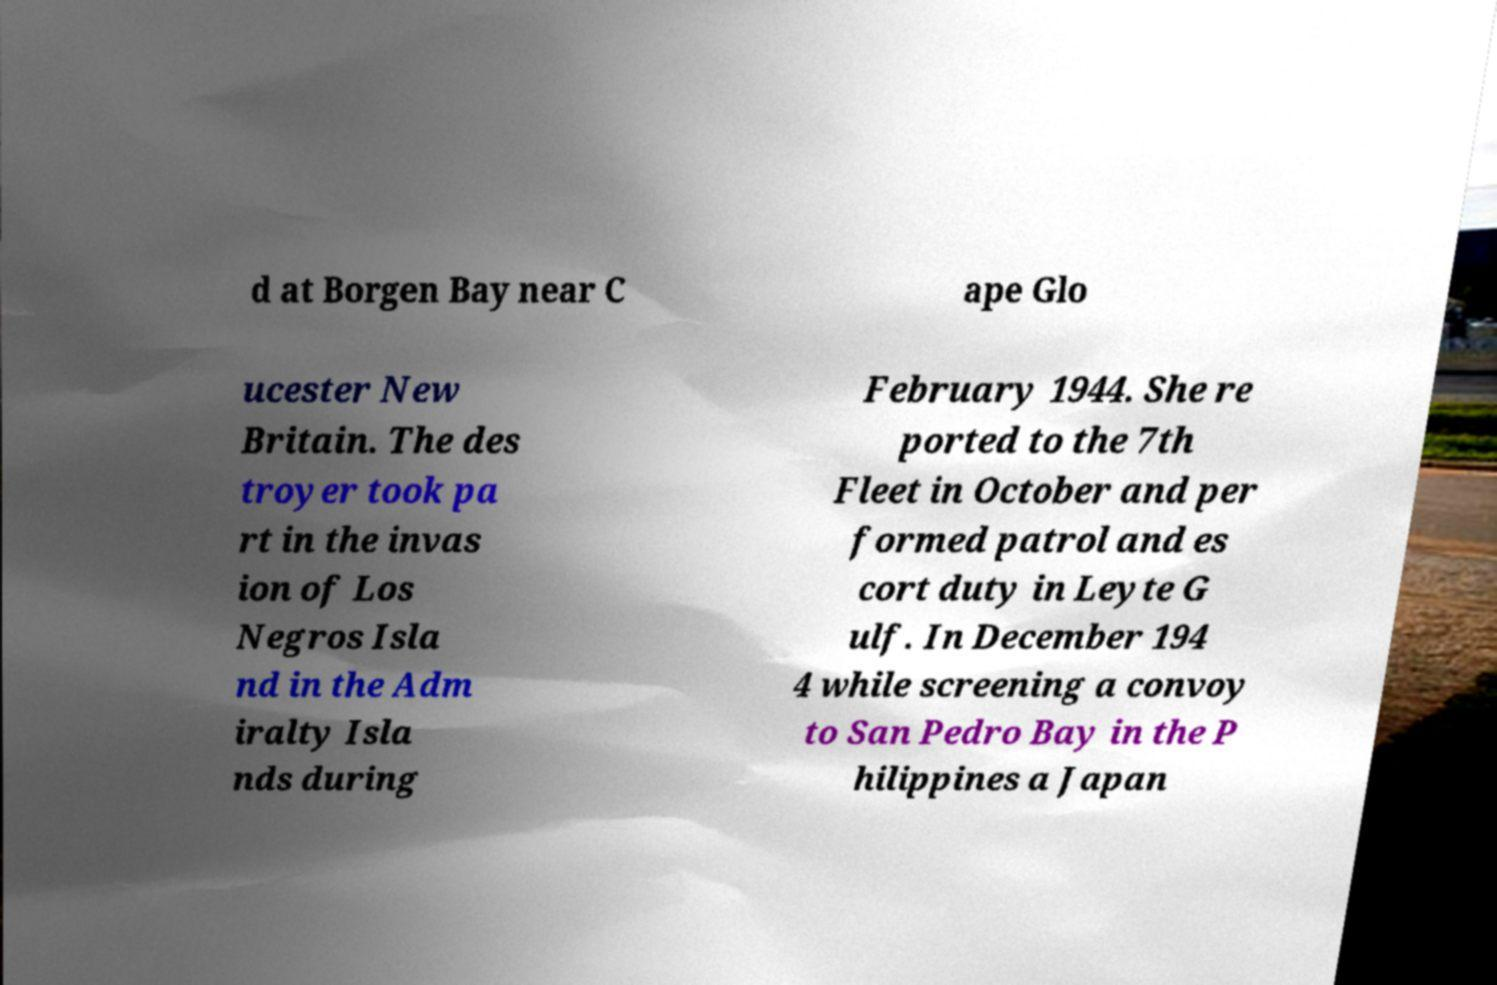Could you assist in decoding the text presented in this image and type it out clearly? d at Borgen Bay near C ape Glo ucester New Britain. The des troyer took pa rt in the invas ion of Los Negros Isla nd in the Adm iralty Isla nds during February 1944. She re ported to the 7th Fleet in October and per formed patrol and es cort duty in Leyte G ulf. In December 194 4 while screening a convoy to San Pedro Bay in the P hilippines a Japan 